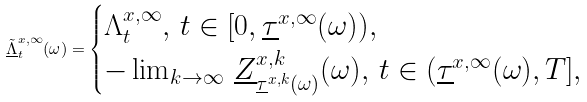<formula> <loc_0><loc_0><loc_500><loc_500>\underline { \tilde { \Lambda } } ^ { x , \infty } _ { t } ( \omega ) = \begin{cases} \Lambda ^ { x , \infty } _ { t } , \, t \in [ 0 , \underline { \tau } ^ { x , \infty } ( \omega ) ) , \\ - \lim _ { k \to \infty } \, \underline { Z } ^ { x , k } _ { \underline { \tau } ^ { x , k } ( \omega ) } ( \omega ) , \, t \in ( \underline { \tau } ^ { x , \infty } ( \omega ) , T ] , \end{cases}</formula> 